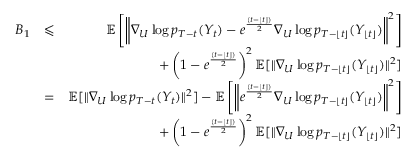Convert formula to latex. <formula><loc_0><loc_0><loc_500><loc_500>\begin{array} { r l r } { B _ { 1 } } & { \leqslant } & { \mathbb { E } \left [ \left \| \nabla _ { U } \log p _ { T - t } ( Y _ { t } ) - e ^ { \frac { ( t - \lfloor t \rfloor ) } { 2 } } \nabla _ { U } \log p _ { T - \lfloor t \rfloor } ( Y _ { \lfloor t \rfloor } ) \right \| ^ { 2 } \right ] } \\ & { + \left ( 1 - e ^ { \frac { ( t - \lfloor t \rfloor ) } { 2 } } \right ) ^ { 2 } \mathbb { E } [ \| \nabla _ { U } \log p _ { T - \lfloor t \rfloor } ( Y _ { \lfloor t \rfloor } ) \| ^ { 2 } ] } \\ & { = } & { \mathbb { E } [ \| \nabla _ { U } \log p _ { T - t } ( Y _ { t } ) \| ^ { 2 } ] - \mathbb { E } \left [ \left \| e ^ { \frac { ( t - \lfloor t \rfloor ) } { 2 } } \nabla _ { U } \log p _ { T - \lfloor t \rfloor } ( Y _ { \lfloor t \rfloor } ) \right \| ^ { 2 } \right ] } \\ & { + \left ( 1 - e ^ { \frac { ( t - \lfloor t \rfloor ) } { 2 } } \right ) ^ { 2 } \mathbb { E } [ \| \nabla _ { U } \log p _ { T - \lfloor t \rfloor } ( Y _ { \lfloor t \rfloor } ) \| ^ { 2 } ] } \end{array}</formula> 